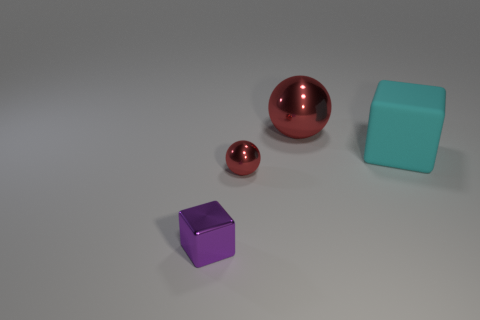Is there any other thing that is made of the same material as the cyan thing?
Give a very brief answer. No. Is there a big red shiny sphere on the left side of the red metallic ball on the right side of the shiny ball left of the large red shiny object?
Offer a very short reply. No. Is the number of big objects that are in front of the large metallic sphere less than the number of big metal things on the left side of the tiny red thing?
Keep it short and to the point. No. What is the shape of the purple thing that is the same material as the tiny red ball?
Make the answer very short. Cube. There is a block to the right of the block that is left of the ball behind the cyan cube; how big is it?
Your answer should be compact. Large. Are there more red shiny objects than small metal balls?
Ensure brevity in your answer.  Yes. There is a metal thing behind the small red sphere; does it have the same color as the metallic sphere that is in front of the matte object?
Keep it short and to the point. Yes. Is the tiny thing to the right of the metal block made of the same material as the large thing that is behind the big matte object?
Keep it short and to the point. Yes. How many purple things are the same size as the purple cube?
Offer a terse response. 0. Is the number of tiny purple shiny cubes less than the number of blue objects?
Offer a very short reply. No. 